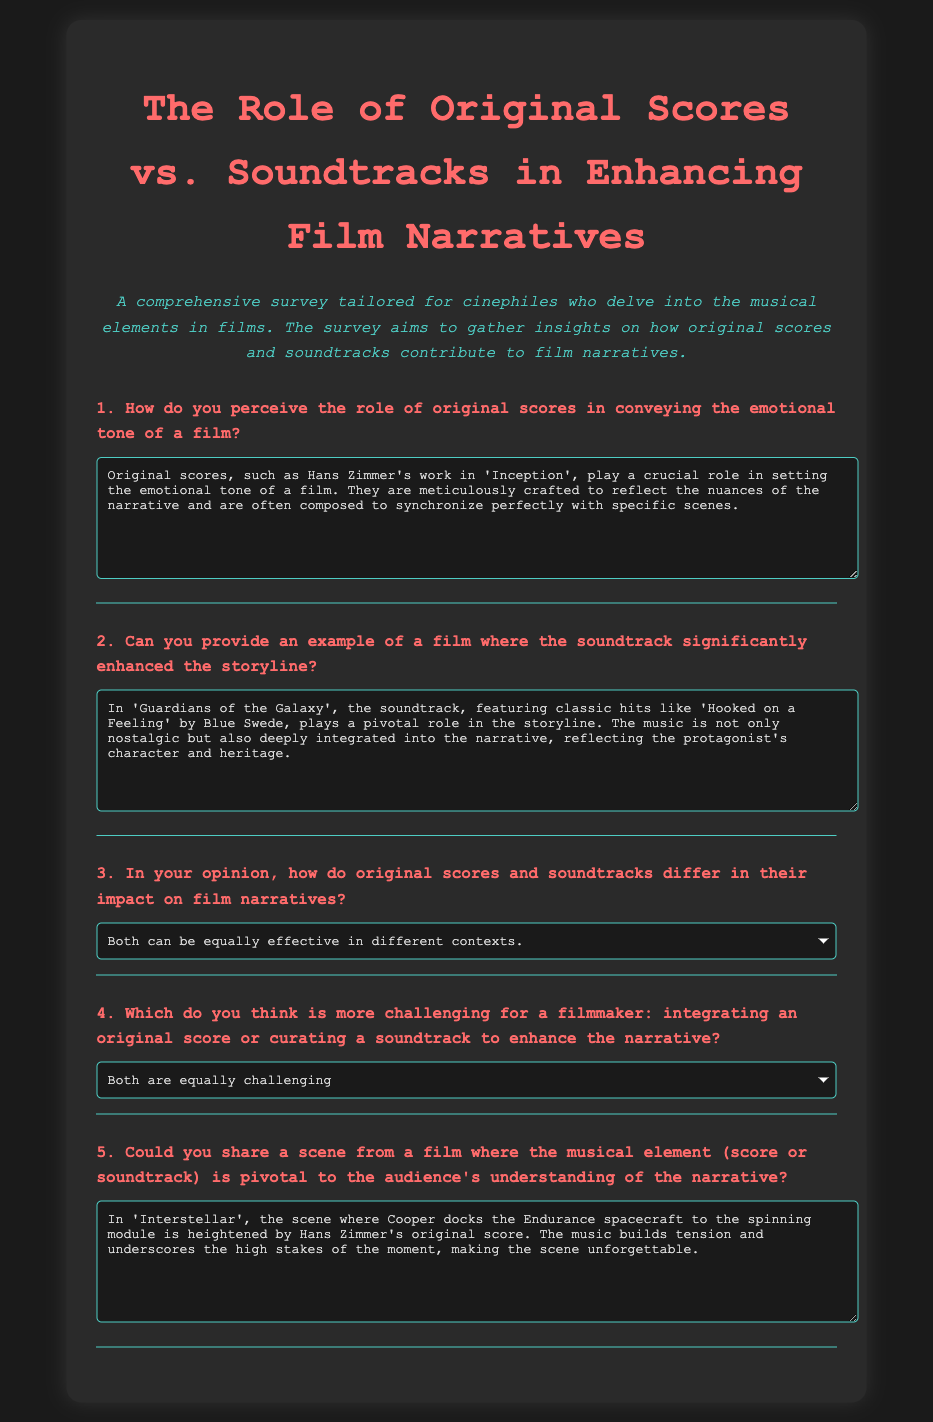What is the title of the survey? The title of the survey is clearly stated at the beginning of the document.
Answer: The Role of Original Scores vs. Soundtracks in Enhancing Film Narratives Who composed the original score for 'Inception'? The respondent mentions Hans Zimmer as the composer of the original score for 'Inception' in their answer.
Answer: Hans Zimmer Which film is cited as an example where the soundtrack enhanced the storyline? The respondent specifically mentions 'Guardians of the Galaxy' as a film where the soundtrack significantly enhanced the storyline.
Answer: Guardians of the Galaxy What musical element is mentioned as pivotal in 'Interstellar'? The answer provided indicates that Hans Zimmer's original score is pivotal in 'Interstellar' during a significant scene.
Answer: Original score What type of question asks for the difference in impact between original scores and soundtracks? The question asking for an opinion on the impact of original scores and soundtracks is a reasoning question that compares both.
Answer: Opinion question What option is selected for the question about integrating an original score or curating a soundtrack? The selected option indicates the respondent's view on the challenges faced when integrating music into a film.
Answer: Both are equally challenging 